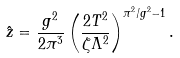<formula> <loc_0><loc_0><loc_500><loc_500>\hat { z } = \frac { g ^ { 2 } } { 2 \pi ^ { 3 } } \left ( \frac { 2 T ^ { 2 } } { \zeta \Lambda ^ { 2 } } \right ) ^ { \pi ^ { 2 } / g ^ { 2 } - 1 } .</formula> 